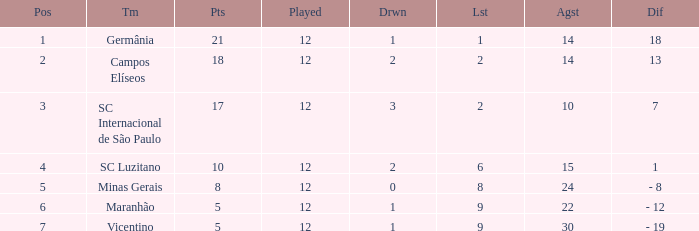Could you help me parse every detail presented in this table? {'header': ['Pos', 'Tm', 'Pts', 'Played', 'Drwn', 'Lst', 'Agst', 'Dif'], 'rows': [['1', 'Germânia', '21', '12', '1', '1', '14', '18'], ['2', 'Campos Elíseos', '18', '12', '2', '2', '14', '13'], ['3', 'SC Internacional de São Paulo', '17', '12', '3', '2', '10', '7'], ['4', 'SC Luzitano', '10', '12', '2', '6', '15', '1'], ['5', 'Minas Gerais', '8', '12', '0', '8', '24', '- 8'], ['6', 'Maranhão', '5', '12', '1', '9', '22', '- 12'], ['7', 'Vicentino', '5', '12', '1', '9', '30', '- 19']]} What is the sum of drawn that has a played more than 12? 0.0. 